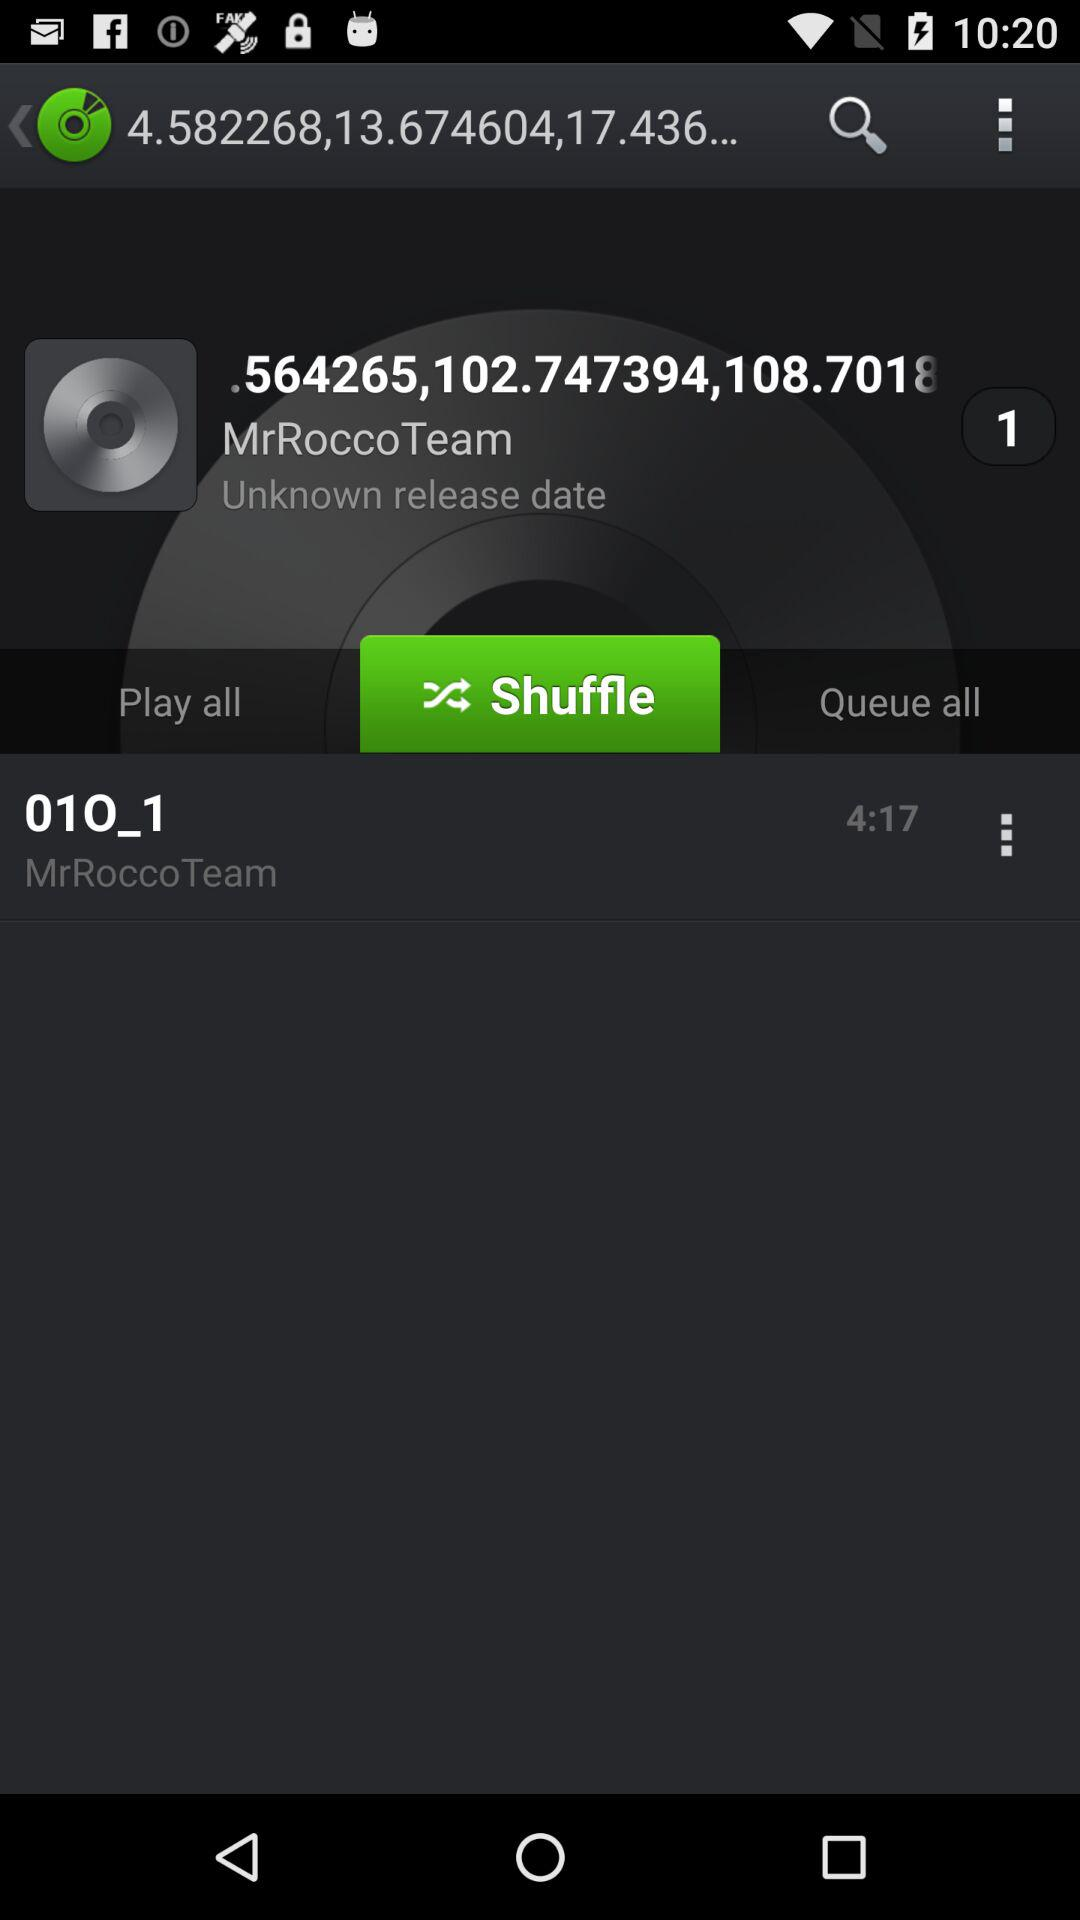What is the duration of the audio? The duration of the audio is 4:17. 